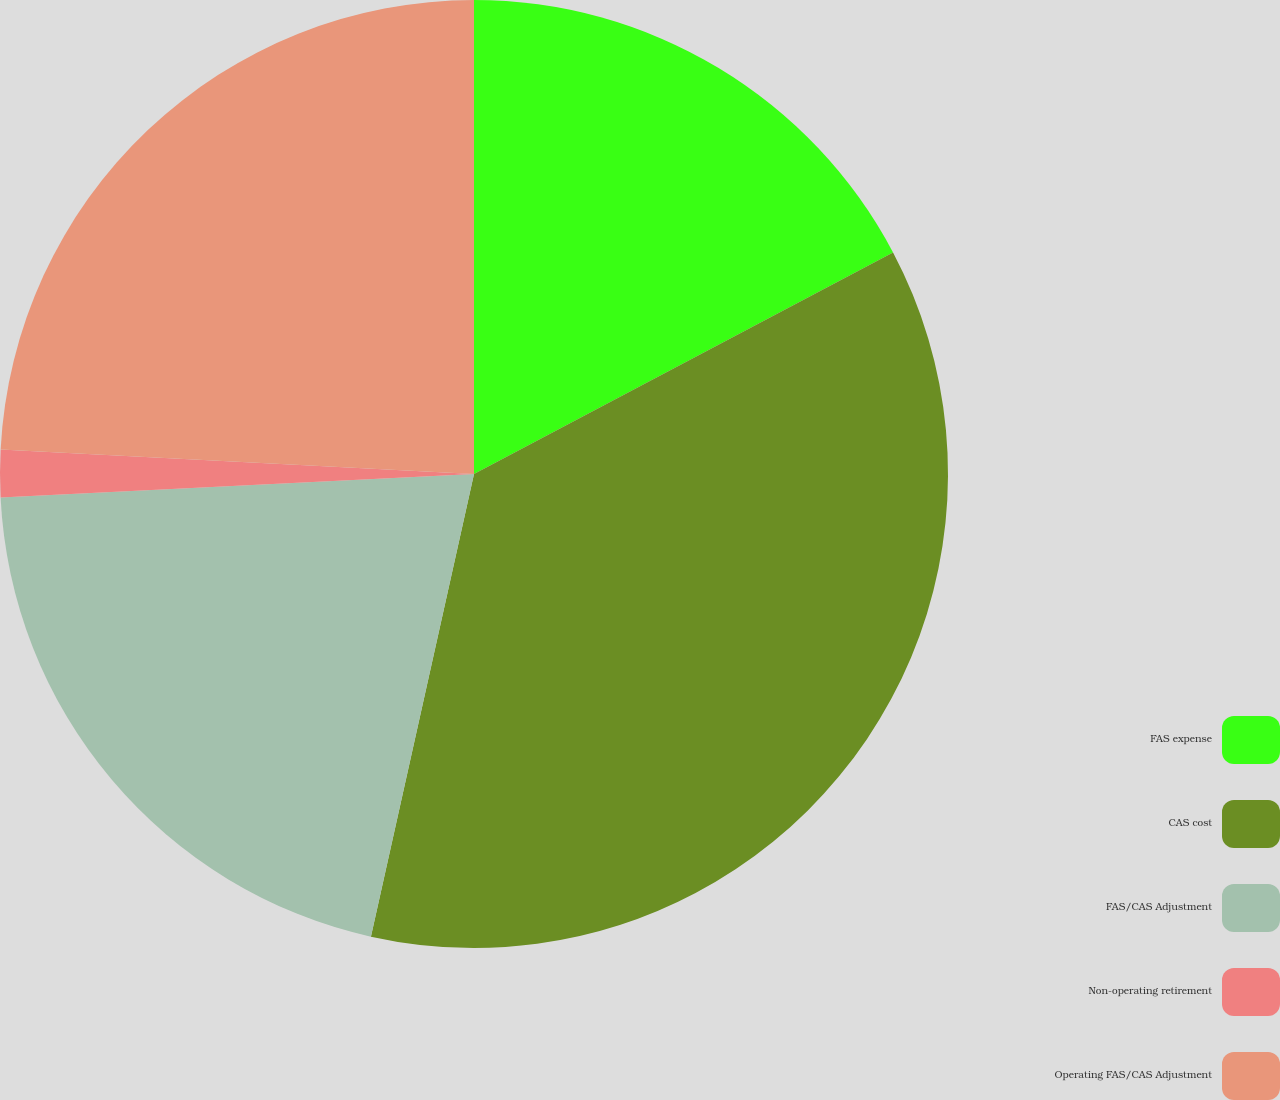<chart> <loc_0><loc_0><loc_500><loc_500><pie_chart><fcel>FAS expense<fcel>CAS cost<fcel>FAS/CAS Adjustment<fcel>Non-operating retirement<fcel>Operating FAS/CAS Adjustment<nl><fcel>17.26%<fcel>36.23%<fcel>20.72%<fcel>1.61%<fcel>24.18%<nl></chart> 